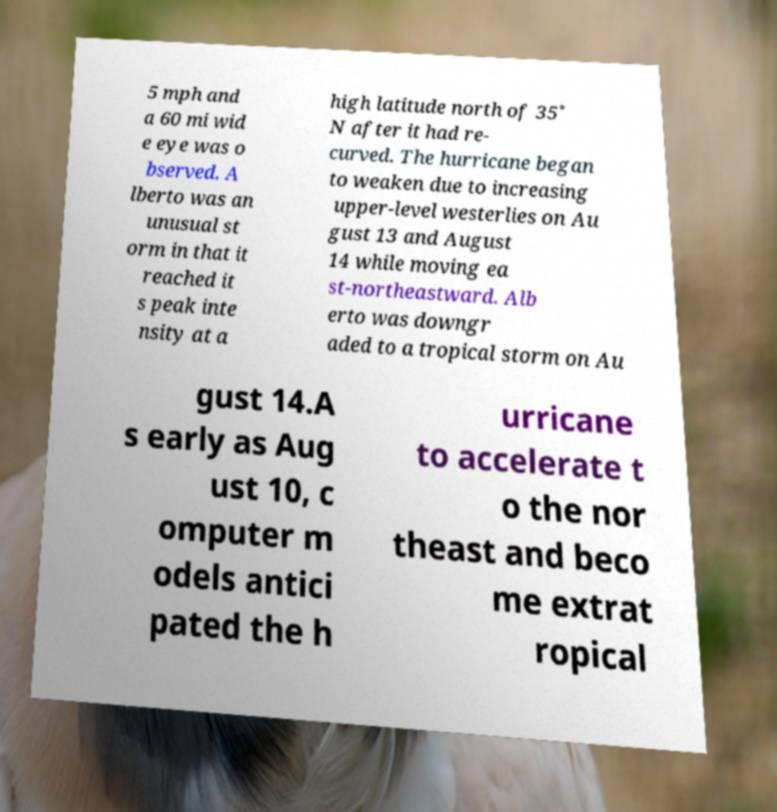For documentation purposes, I need the text within this image transcribed. Could you provide that? 5 mph and a 60 mi wid e eye was o bserved. A lberto was an unusual st orm in that it reached it s peak inte nsity at a high latitude north of 35˚ N after it had re- curved. The hurricane began to weaken due to increasing upper-level westerlies on Au gust 13 and August 14 while moving ea st-northeastward. Alb erto was downgr aded to a tropical storm on Au gust 14.A s early as Aug ust 10, c omputer m odels antici pated the h urricane to accelerate t o the nor theast and beco me extrat ropical 